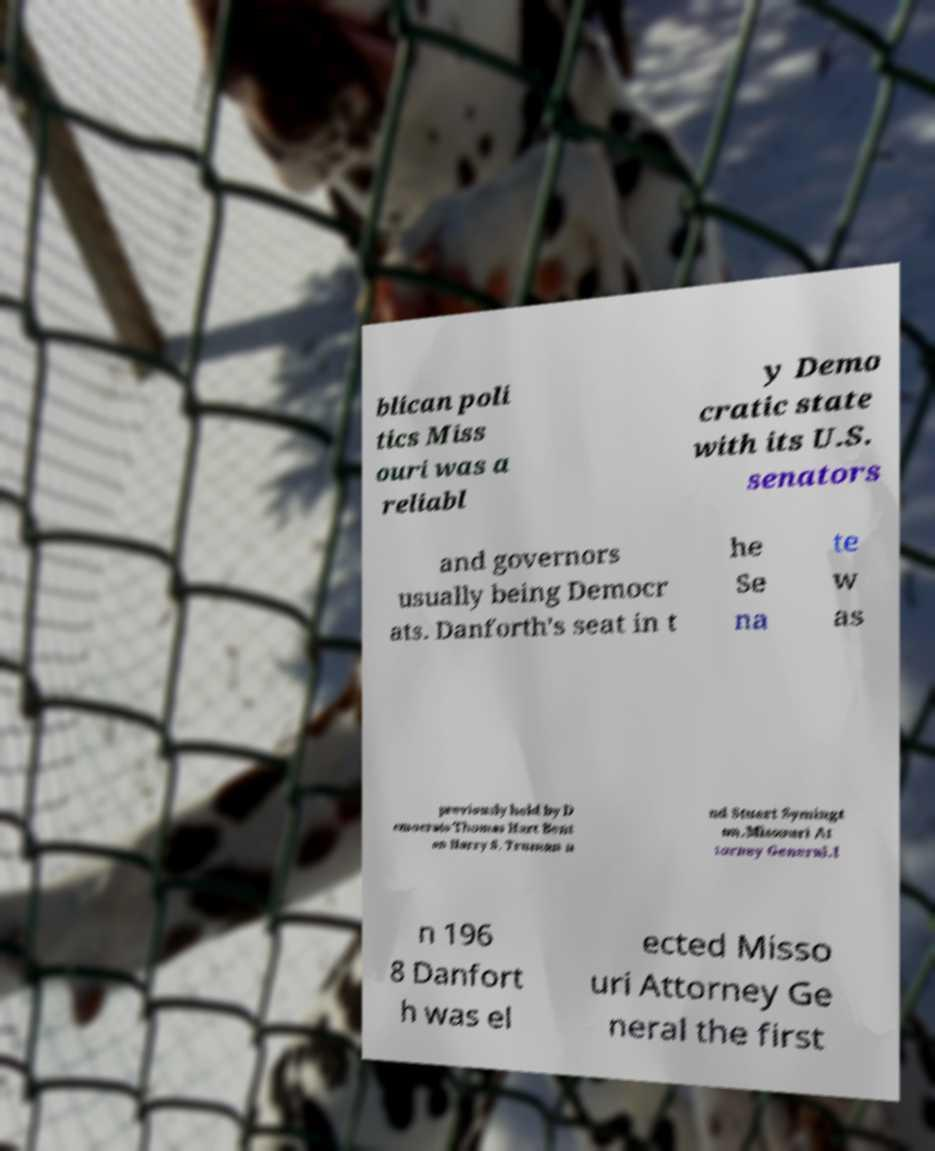Can you read and provide the text displayed in the image?This photo seems to have some interesting text. Can you extract and type it out for me? blican poli tics Miss ouri was a reliabl y Demo cratic state with its U.S. senators and governors usually being Democr ats. Danforth's seat in t he Se na te w as previously held by D emocrats Thomas Hart Bent on Harry S. Truman a nd Stuart Symingt on.Missouri At torney General.I n 196 8 Danfort h was el ected Misso uri Attorney Ge neral the first 